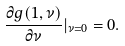<formula> <loc_0><loc_0><loc_500><loc_500>\frac { \partial g ( 1 , \nu ) } { \partial \nu } | _ { \nu = 0 } = 0 .</formula> 